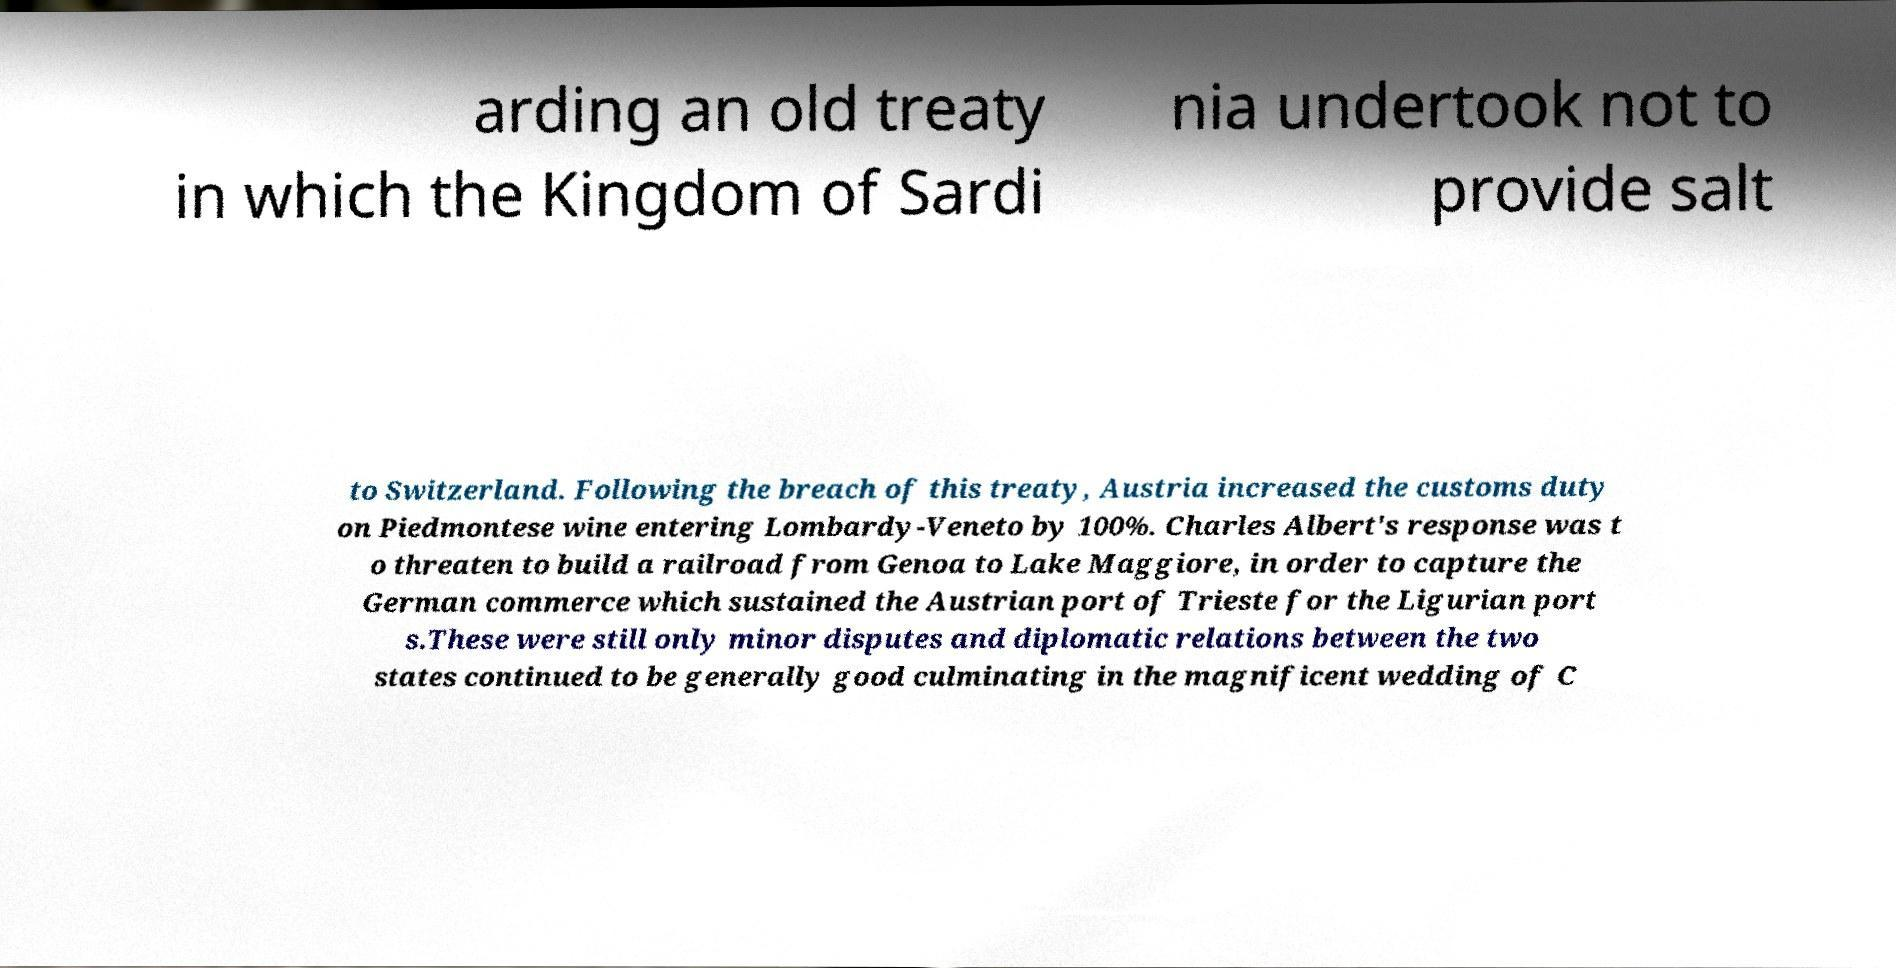What messages or text are displayed in this image? I need them in a readable, typed format. arding an old treaty in which the Kingdom of Sardi nia undertook not to provide salt to Switzerland. Following the breach of this treaty, Austria increased the customs duty on Piedmontese wine entering Lombardy-Veneto by 100%. Charles Albert's response was t o threaten to build a railroad from Genoa to Lake Maggiore, in order to capture the German commerce which sustained the Austrian port of Trieste for the Ligurian port s.These were still only minor disputes and diplomatic relations between the two states continued to be generally good culminating in the magnificent wedding of C 